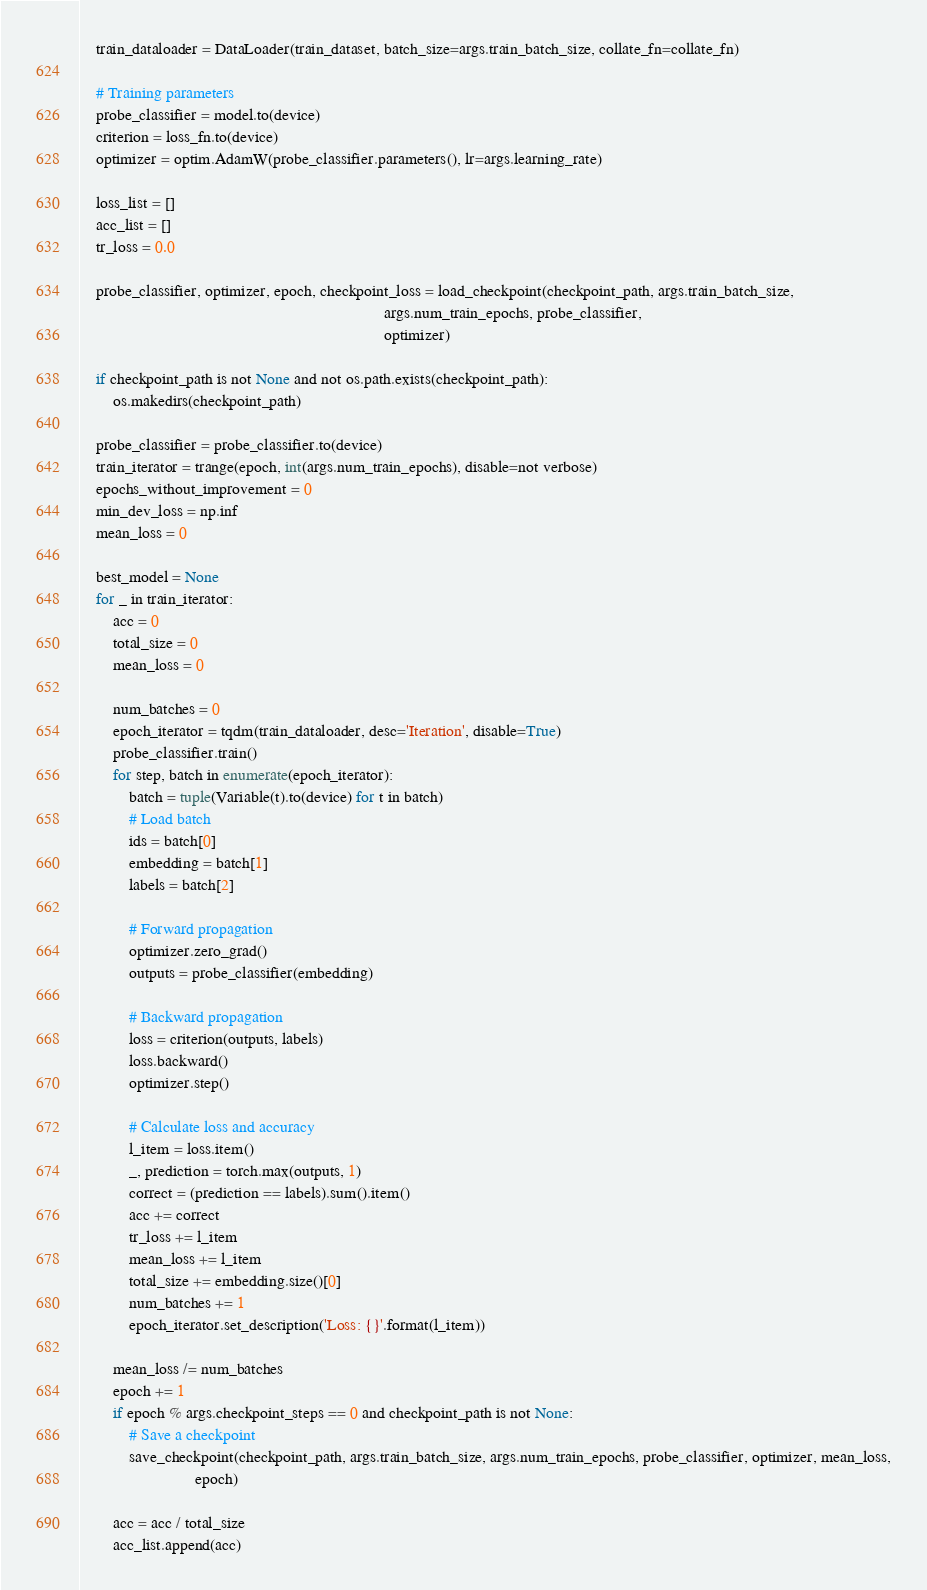Convert code to text. <code><loc_0><loc_0><loc_500><loc_500><_Python_>
    train_dataloader = DataLoader(train_dataset, batch_size=args.train_batch_size, collate_fn=collate_fn)

    # Training parameters
    probe_classifier = model.to(device)
    criterion = loss_fn.to(device)
    optimizer = optim.AdamW(probe_classifier.parameters(), lr=args.learning_rate)

    loss_list = []
    acc_list = []
    tr_loss = 0.0

    probe_classifier, optimizer, epoch, checkpoint_loss = load_checkpoint(checkpoint_path, args.train_batch_size,
                                                                          args.num_train_epochs, probe_classifier,
                                                                          optimizer)

    if checkpoint_path is not None and not os.path.exists(checkpoint_path):
        os.makedirs(checkpoint_path)

    probe_classifier = probe_classifier.to(device)
    train_iterator = trange(epoch, int(args.num_train_epochs), disable=not verbose)
    epochs_without_improvement = 0
    min_dev_loss = np.inf
    mean_loss = 0

    best_model = None
    for _ in train_iterator:
        acc = 0
        total_size = 0
        mean_loss = 0

        num_batches = 0
        epoch_iterator = tqdm(train_dataloader, desc='Iteration', disable=True)
        probe_classifier.train()
        for step, batch in enumerate(epoch_iterator):
            batch = tuple(Variable(t).to(device) for t in batch)
            # Load batch
            ids = batch[0]
            embedding = batch[1]
            labels = batch[2]

            # Forward propagation
            optimizer.zero_grad()
            outputs = probe_classifier(embedding)

            # Backward propagation
            loss = criterion(outputs, labels)
            loss.backward()
            optimizer.step()

            # Calculate loss and accuracy
            l_item = loss.item()
            _, prediction = torch.max(outputs, 1)
            correct = (prediction == labels).sum().item()
            acc += correct
            tr_loss += l_item
            mean_loss += l_item
            total_size += embedding.size()[0]
            num_batches += 1
            epoch_iterator.set_description('Loss: {}'.format(l_item))

        mean_loss /= num_batches
        epoch += 1
        if epoch % args.checkpoint_steps == 0 and checkpoint_path is not None:
            # Save a checkpoint
            save_checkpoint(checkpoint_path, args.train_batch_size, args.num_train_epochs, probe_classifier, optimizer, mean_loss,
                            epoch)

        acc = acc / total_size
        acc_list.append(acc)</code> 